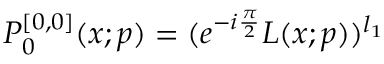<formula> <loc_0><loc_0><loc_500><loc_500>P _ { 0 } ^ { [ 0 , 0 ] } ( x ; p ) = ( e ^ { - i \frac { \pi } { 2 } } L ( x ; p ) ) ^ { l _ { 1 } }</formula> 